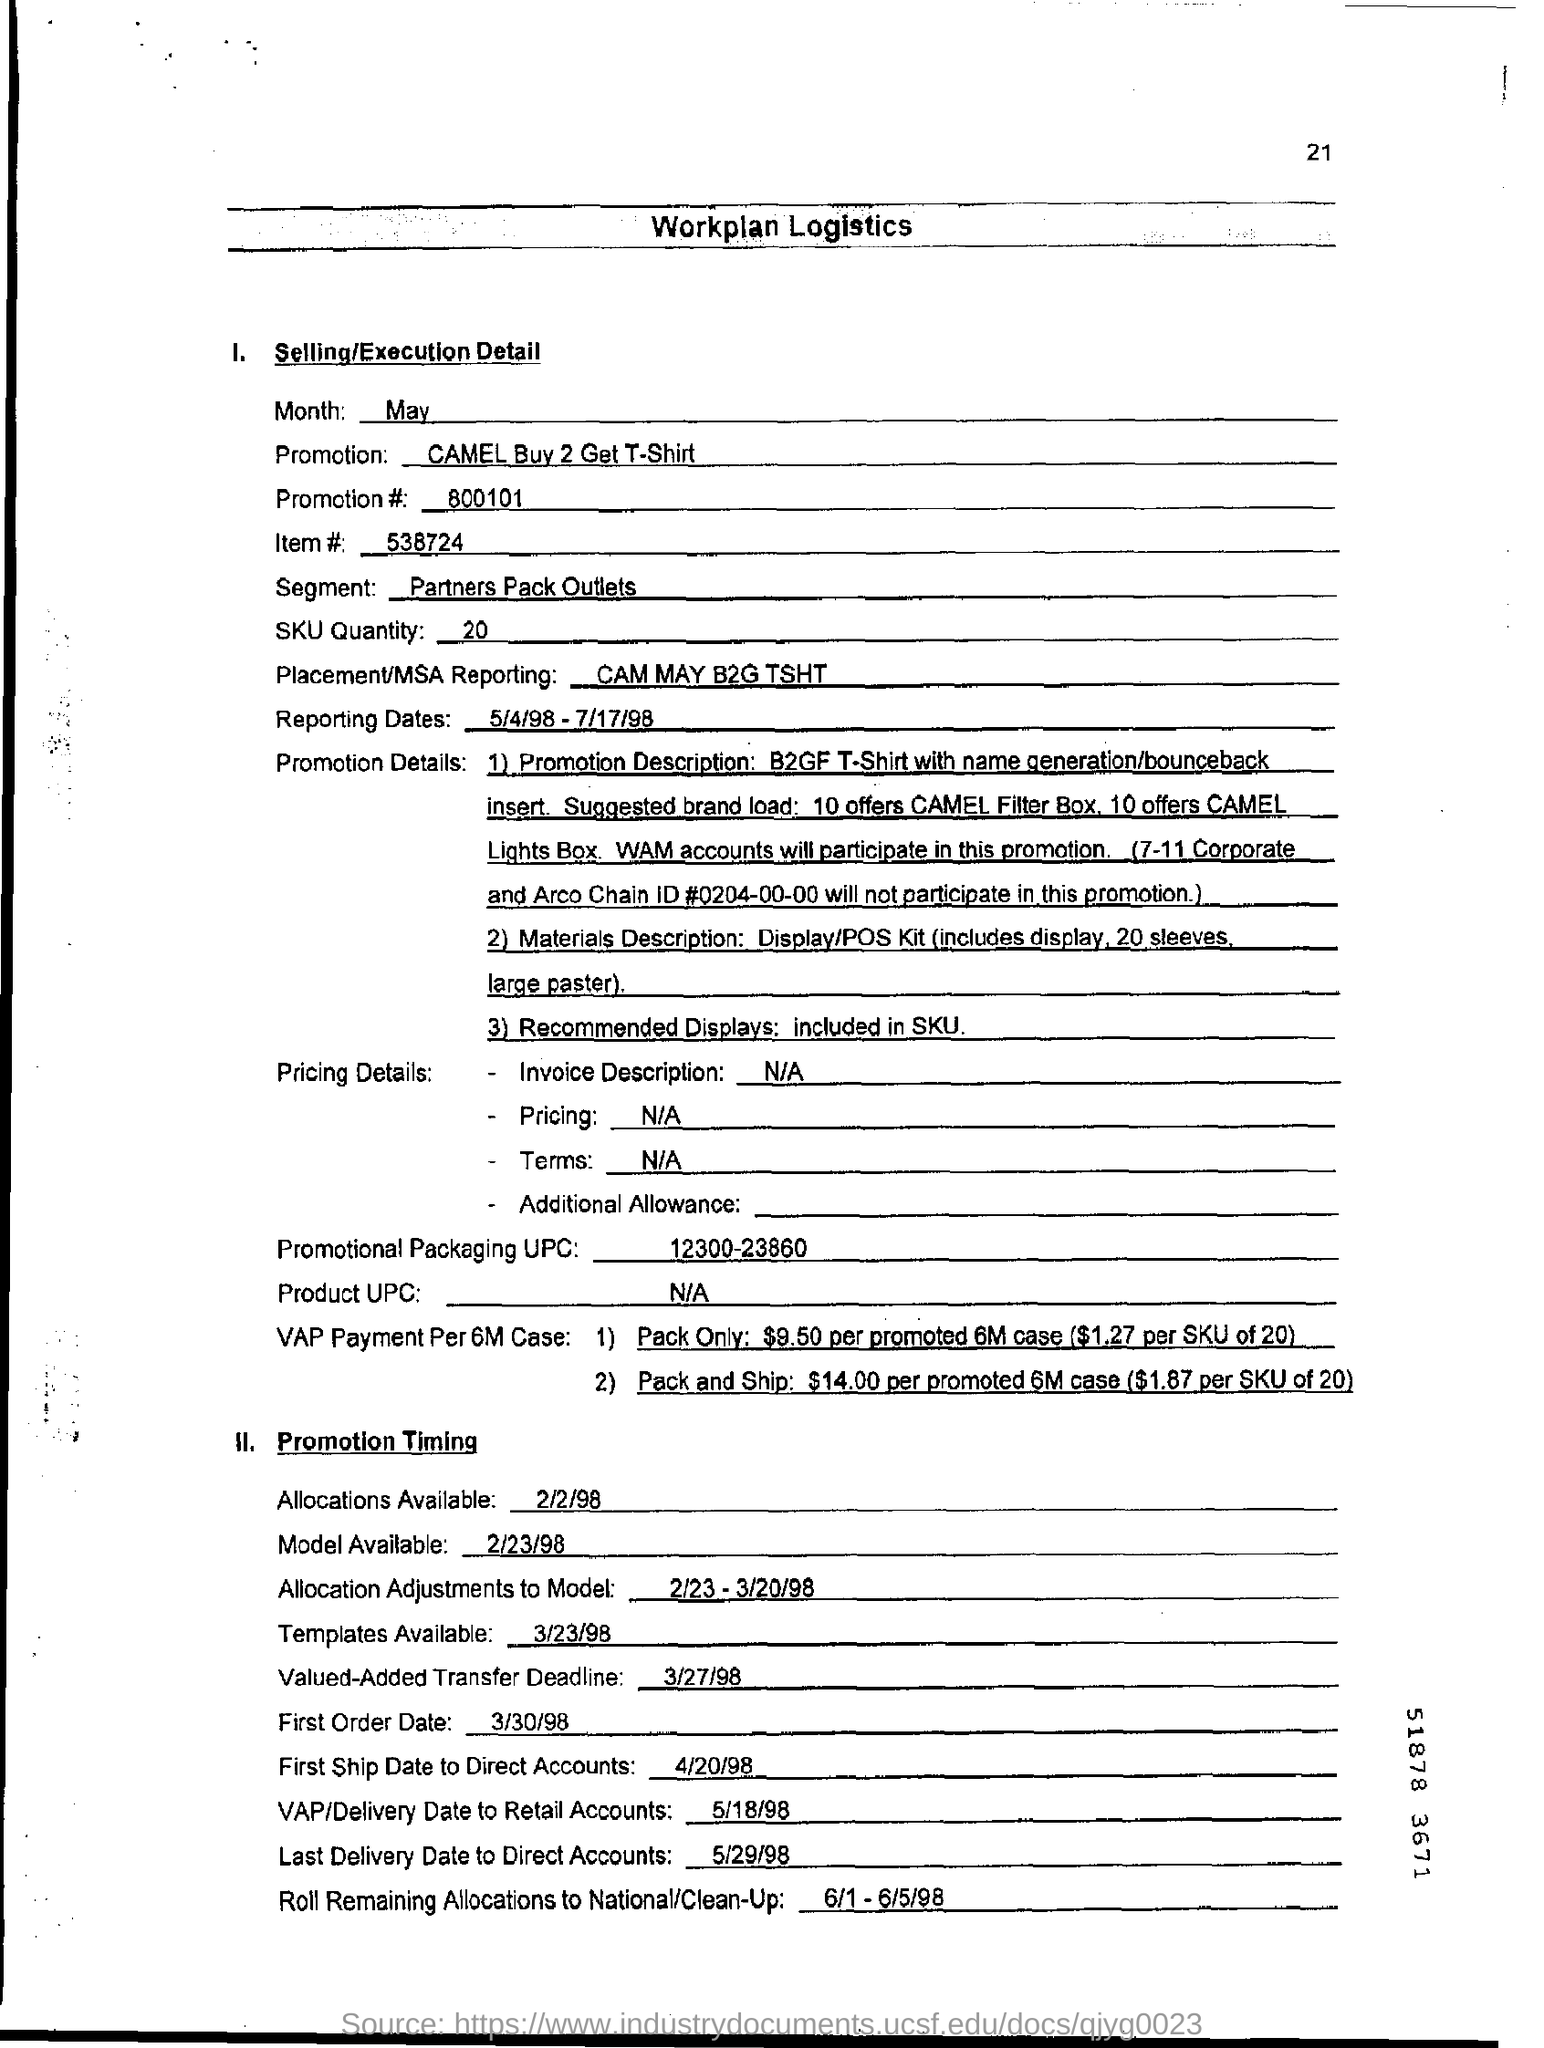Outline some significant characteristics in this image. The SKU quantity is 20. Could you please provide the promotion number? It is 800101...". What is the placement/MSA reporting? CAM may B2G TSHT... The first ship date to direct accounts is April 20, 1998. What is the segment?" is a question asking for information about a particular topic.
"Partners pack outlets" is a noun phrase describing a group of entities that are involved in some way.
"What is the segment ?" and "partners pack outlets" together form a question asking for information about a particular topic and describing a group of entities that are involved in some way. 